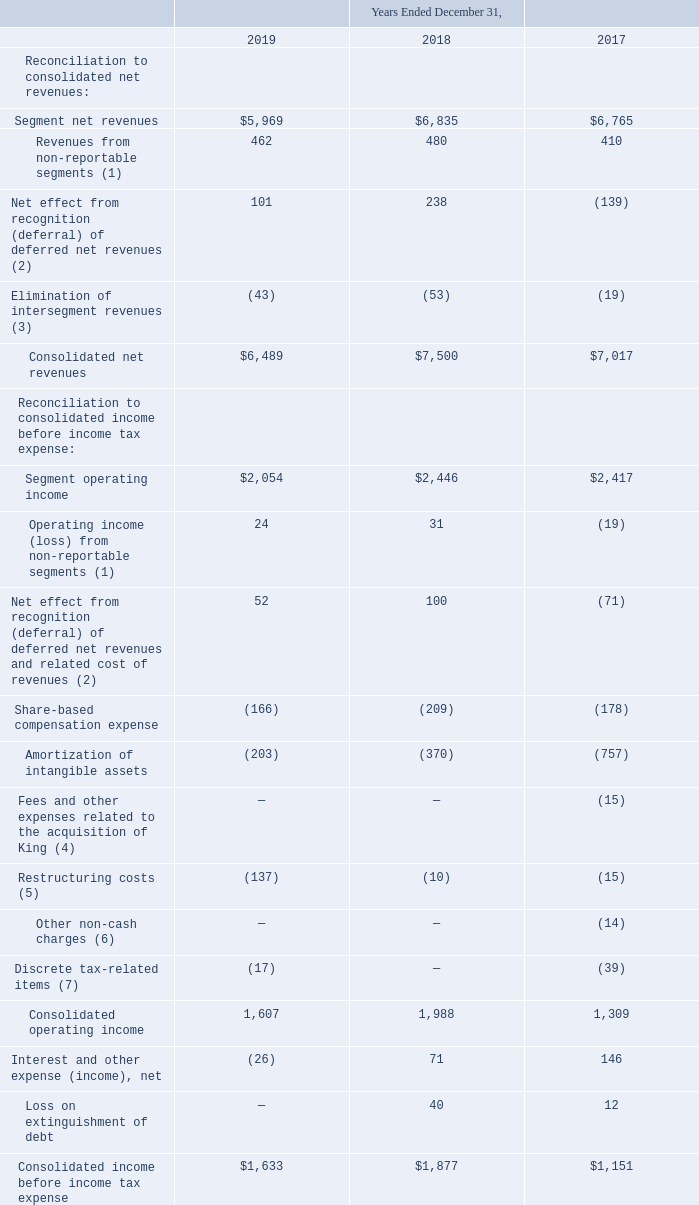Notes to Consolidated Financial Statements (continued)
Reconciliations of total segment net revenues and total segment operating income to consolidated net revenues and consolidated income before income tax expense are presented in the table below (amounts in millions):
(1) Includes other income and expenses from operating segments managed outside the reportable segments, including our Distribution business. Also includes unallocated corporate income and expenses.
(2) Reflects the net effect from recognition (deferral) of deferred net revenues, along with related cost of revenues, on certain of our online-enabled products.
(3) Intersegment revenues reflect licensing and service fees charged between segments.
(4) Reflects fees and other expenses, such as legal, banking, and professional services fees, related to the acquisition of King and associated integration activities, including related debt financings.
(5) Reflects restructuring initiatives, which include severance and other restructuring-related costs.
(6) Reflects a non-cash accounting charge to reclassify certain cumulative translation gains (losses) into earnings due to the substantial liquidation of certain of our foreign entities.
(7) Reflects the impact of other unusual or unique tax-related items and activities.
What do intersegment revenues reflect? Licensing and service fees charged between segments. What was the segment net revenue in 2019?
Answer scale should be: million. $5,969. What was the revenues from non-reportable segments in 2017?
Answer scale should be: million. 410. What was the percentage change in segment net revenues between 2018 and 2019?
Answer scale should be: percent. ($5,969-$6,835)/$6,835
Answer: -12.67. What was the percentage change in segment operating income before income tax expense between 2017 and 2018?
Answer scale should be: percent. ($2,446-$2,417)/$2,417
Answer: 1.2. What was the change in consolidated net revenues between 2018 and 2019?
Answer scale should be: million. ($6,489-$7,500)
Answer: -1011. 